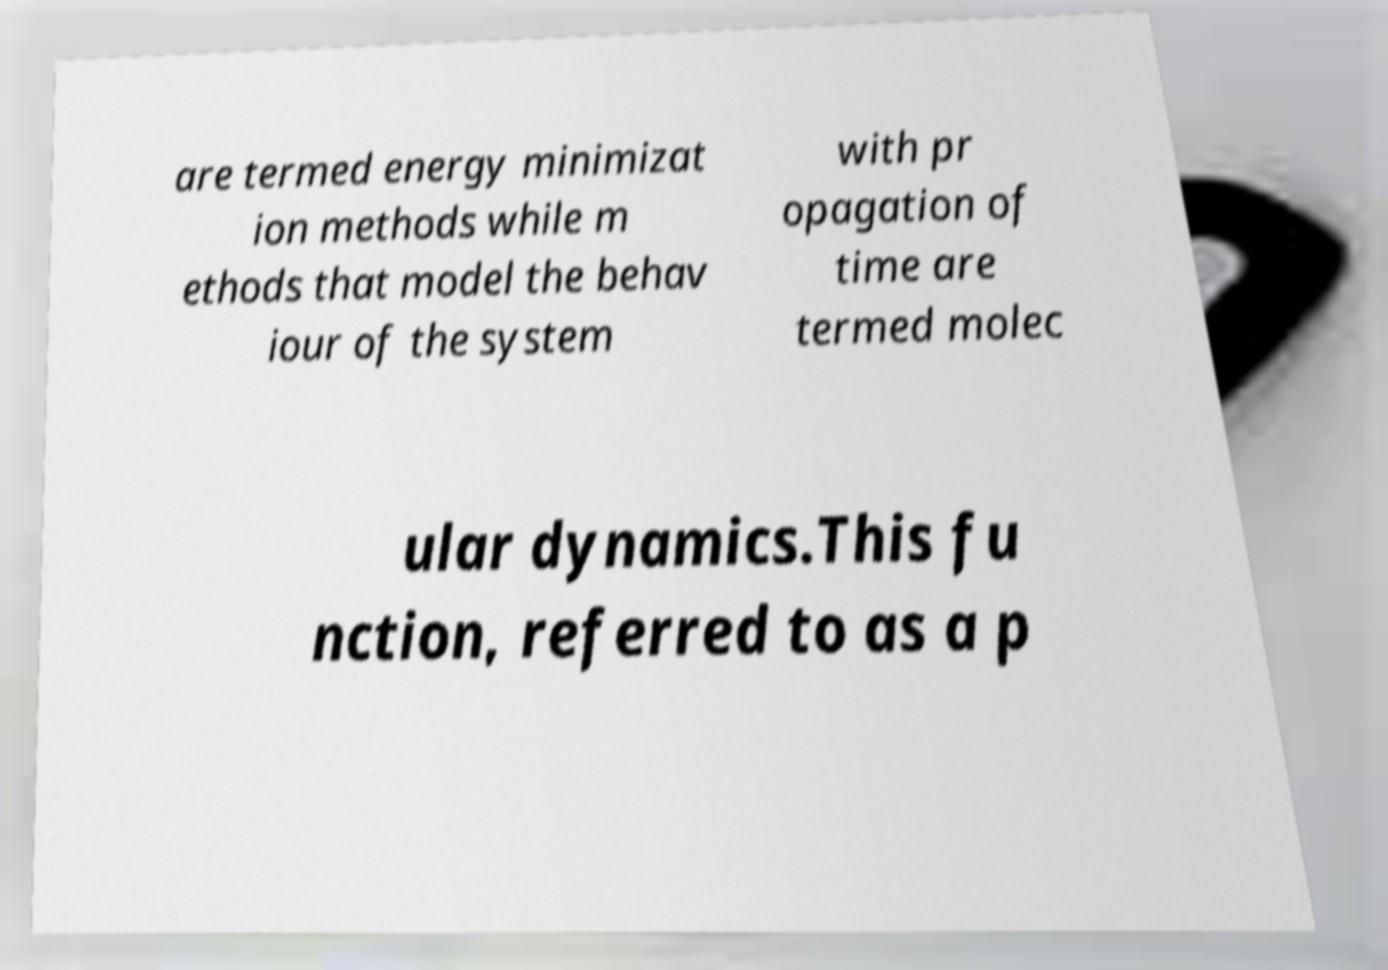Please read and relay the text visible in this image. What does it say? are termed energy minimizat ion methods while m ethods that model the behav iour of the system with pr opagation of time are termed molec ular dynamics.This fu nction, referred to as a p 